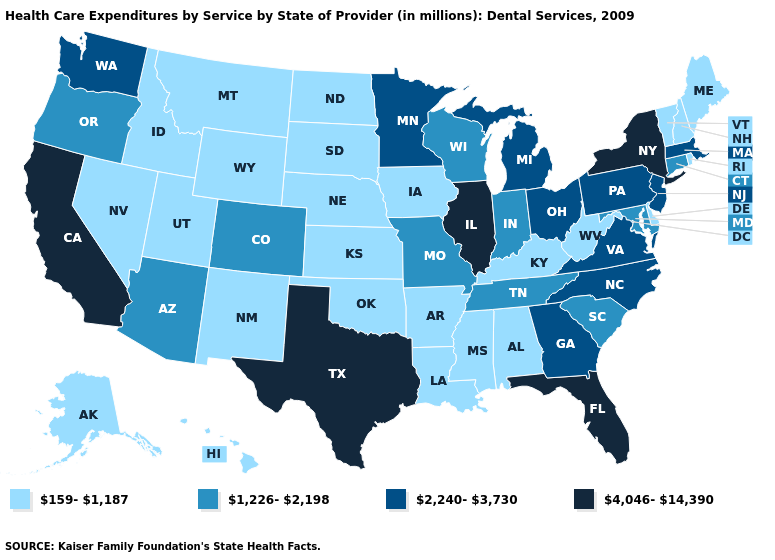Which states have the lowest value in the South?
Give a very brief answer. Alabama, Arkansas, Delaware, Kentucky, Louisiana, Mississippi, Oklahoma, West Virginia. Name the states that have a value in the range 2,240-3,730?
Short answer required. Georgia, Massachusetts, Michigan, Minnesota, New Jersey, North Carolina, Ohio, Pennsylvania, Virginia, Washington. Name the states that have a value in the range 159-1,187?
Give a very brief answer. Alabama, Alaska, Arkansas, Delaware, Hawaii, Idaho, Iowa, Kansas, Kentucky, Louisiana, Maine, Mississippi, Montana, Nebraska, Nevada, New Hampshire, New Mexico, North Dakota, Oklahoma, Rhode Island, South Dakota, Utah, Vermont, West Virginia, Wyoming. Does Georgia have a lower value than Texas?
Write a very short answer. Yes. What is the value of North Dakota?
Quick response, please. 159-1,187. Does Florida have the lowest value in the South?
Answer briefly. No. Does Nebraska have the lowest value in the MidWest?
Give a very brief answer. Yes. Among the states that border California , does Nevada have the lowest value?
Give a very brief answer. Yes. What is the lowest value in the USA?
Write a very short answer. 159-1,187. Name the states that have a value in the range 4,046-14,390?
Short answer required. California, Florida, Illinois, New York, Texas. Name the states that have a value in the range 2,240-3,730?
Short answer required. Georgia, Massachusetts, Michigan, Minnesota, New Jersey, North Carolina, Ohio, Pennsylvania, Virginia, Washington. Among the states that border Massachusetts , does Connecticut have the lowest value?
Answer briefly. No. Does the map have missing data?
Give a very brief answer. No. Which states have the lowest value in the South?
Keep it brief. Alabama, Arkansas, Delaware, Kentucky, Louisiana, Mississippi, Oklahoma, West Virginia. Does the map have missing data?
Give a very brief answer. No. 